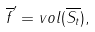Convert formula to latex. <formula><loc_0><loc_0><loc_500><loc_500>\overline { f } ^ { \prime } = v o l ( \overline { S _ { t } } ) ,</formula> 